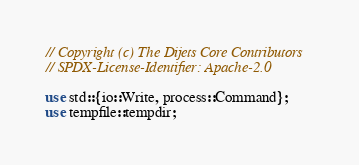<code> <loc_0><loc_0><loc_500><loc_500><_Rust_>// Copyright (c) The Dijets Core Contributors
// SPDX-License-Identifier: Apache-2.0

use std::{io::Write, process::Command};
use tempfile::tempdir;
</code> 